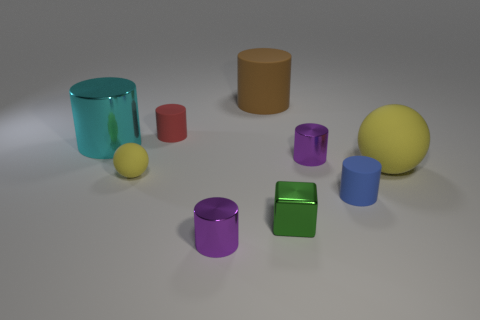Subtract all tiny metallic cylinders. How many cylinders are left? 4 Subtract all gray balls. How many purple cylinders are left? 2 Add 1 small green blocks. How many objects exist? 10 Subtract all blocks. How many objects are left? 8 Subtract all brown cylinders. How many cylinders are left? 5 Subtract 3 cylinders. How many cylinders are left? 3 Subtract all red cylinders. Subtract all purple spheres. How many cylinders are left? 5 Subtract all red matte blocks. Subtract all small green shiny things. How many objects are left? 8 Add 8 tiny cubes. How many tiny cubes are left? 9 Add 2 big yellow rubber balls. How many big yellow rubber balls exist? 3 